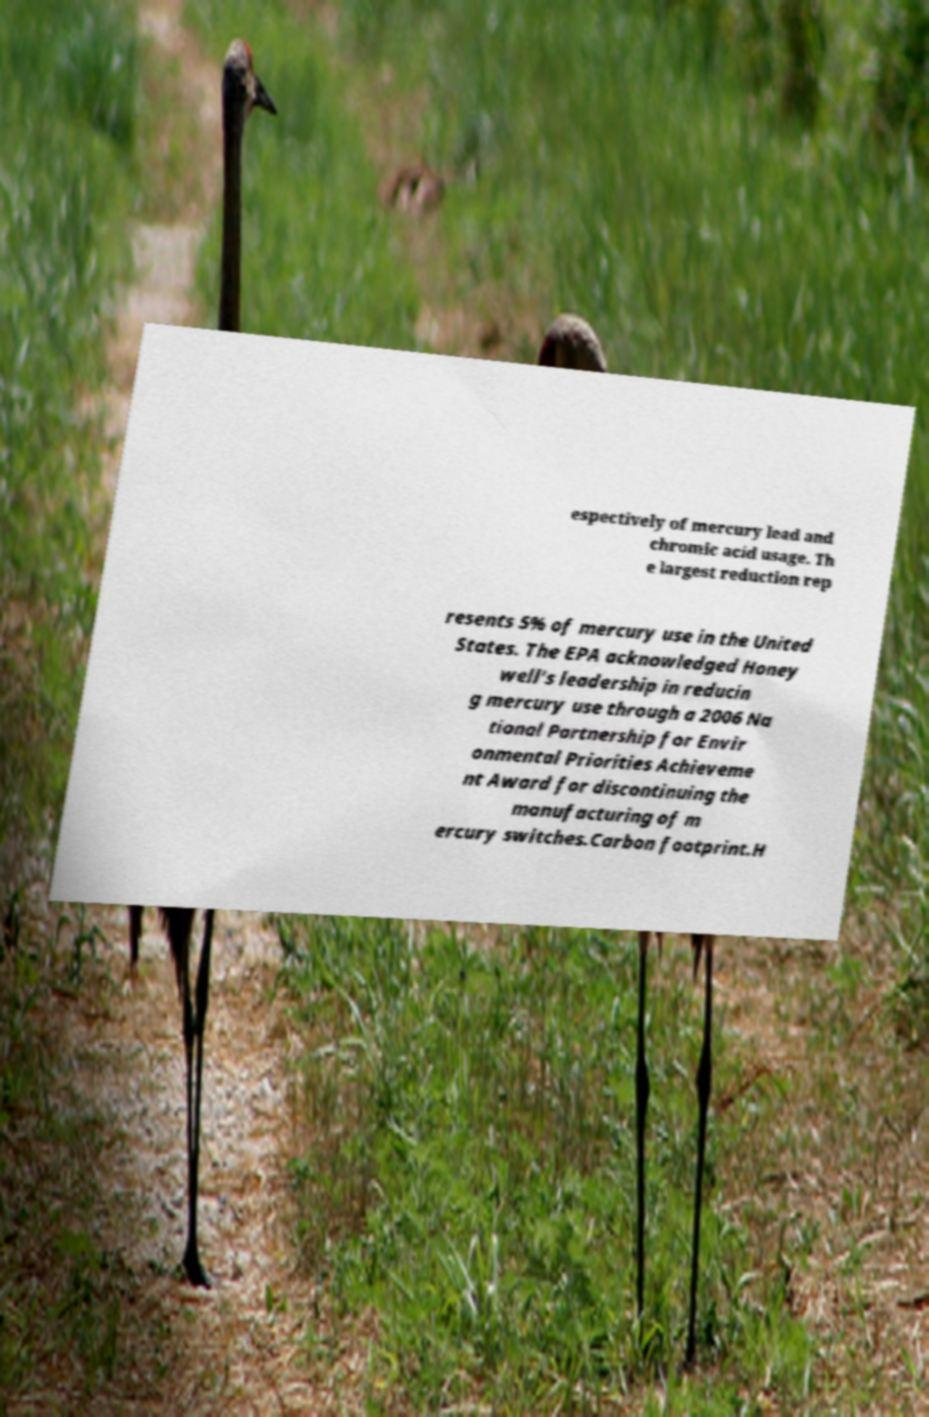I need the written content from this picture converted into text. Can you do that? espectively of mercury lead and chromic acid usage. Th e largest reduction rep resents 5% of mercury use in the United States. The EPA acknowledged Honey well's leadership in reducin g mercury use through a 2006 Na tional Partnership for Envir onmental Priorities Achieveme nt Award for discontinuing the manufacturing of m ercury switches.Carbon footprint.H 